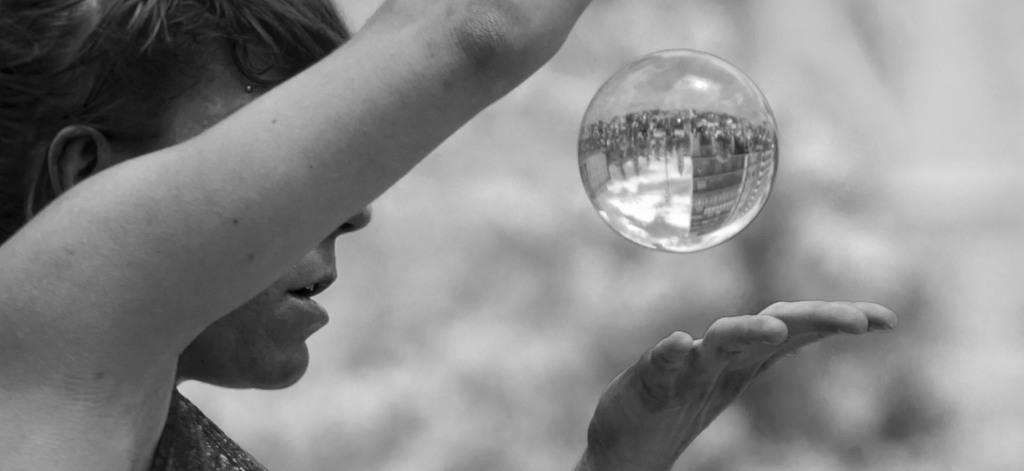Who or what is the main subject in the image? There is a person in the image. What part of the person's body is visible? The person's hands are visible. What type of object is present in the image? There is a round object in the image. How is the round object depicted in the image? The round object is blurred in the background. What color scheme is used in the image? The image is black and white. What type of rail can be seen in the image? There is no rail present in the image. Is there a stage visible in the image? There is no stage present in the image. 